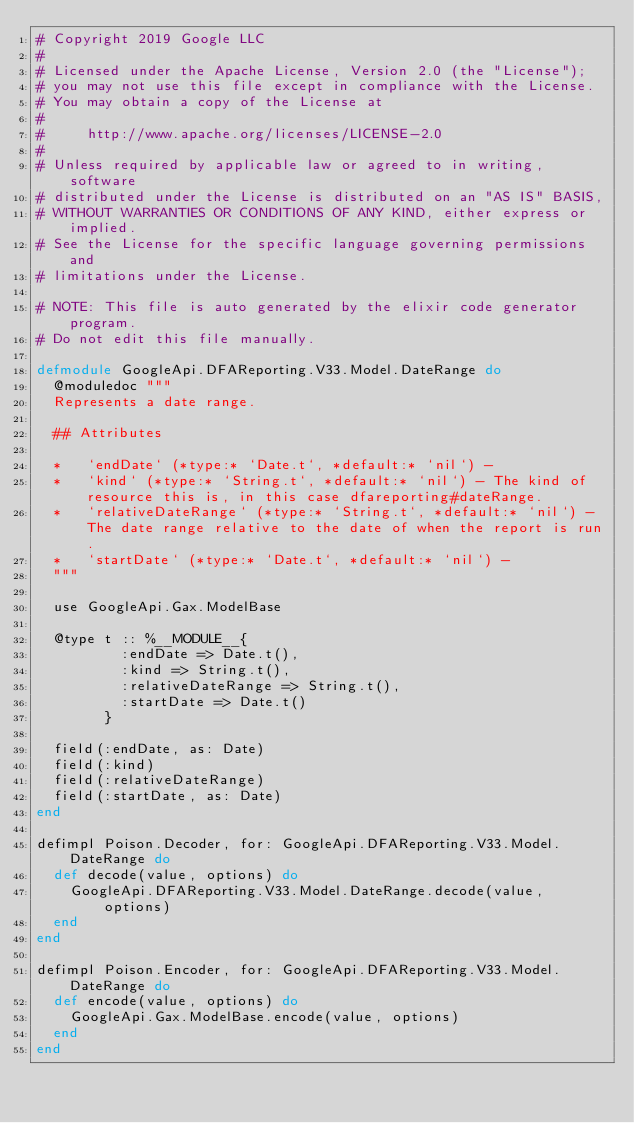<code> <loc_0><loc_0><loc_500><loc_500><_Elixir_># Copyright 2019 Google LLC
#
# Licensed under the Apache License, Version 2.0 (the "License");
# you may not use this file except in compliance with the License.
# You may obtain a copy of the License at
#
#     http://www.apache.org/licenses/LICENSE-2.0
#
# Unless required by applicable law or agreed to in writing, software
# distributed under the License is distributed on an "AS IS" BASIS,
# WITHOUT WARRANTIES OR CONDITIONS OF ANY KIND, either express or implied.
# See the License for the specific language governing permissions and
# limitations under the License.

# NOTE: This file is auto generated by the elixir code generator program.
# Do not edit this file manually.

defmodule GoogleApi.DFAReporting.V33.Model.DateRange do
  @moduledoc """
  Represents a date range.

  ## Attributes

  *   `endDate` (*type:* `Date.t`, *default:* `nil`) - 
  *   `kind` (*type:* `String.t`, *default:* `nil`) - The kind of resource this is, in this case dfareporting#dateRange.
  *   `relativeDateRange` (*type:* `String.t`, *default:* `nil`) - The date range relative to the date of when the report is run.
  *   `startDate` (*type:* `Date.t`, *default:* `nil`) - 
  """

  use GoogleApi.Gax.ModelBase

  @type t :: %__MODULE__{
          :endDate => Date.t(),
          :kind => String.t(),
          :relativeDateRange => String.t(),
          :startDate => Date.t()
        }

  field(:endDate, as: Date)
  field(:kind)
  field(:relativeDateRange)
  field(:startDate, as: Date)
end

defimpl Poison.Decoder, for: GoogleApi.DFAReporting.V33.Model.DateRange do
  def decode(value, options) do
    GoogleApi.DFAReporting.V33.Model.DateRange.decode(value, options)
  end
end

defimpl Poison.Encoder, for: GoogleApi.DFAReporting.V33.Model.DateRange do
  def encode(value, options) do
    GoogleApi.Gax.ModelBase.encode(value, options)
  end
end
</code> 